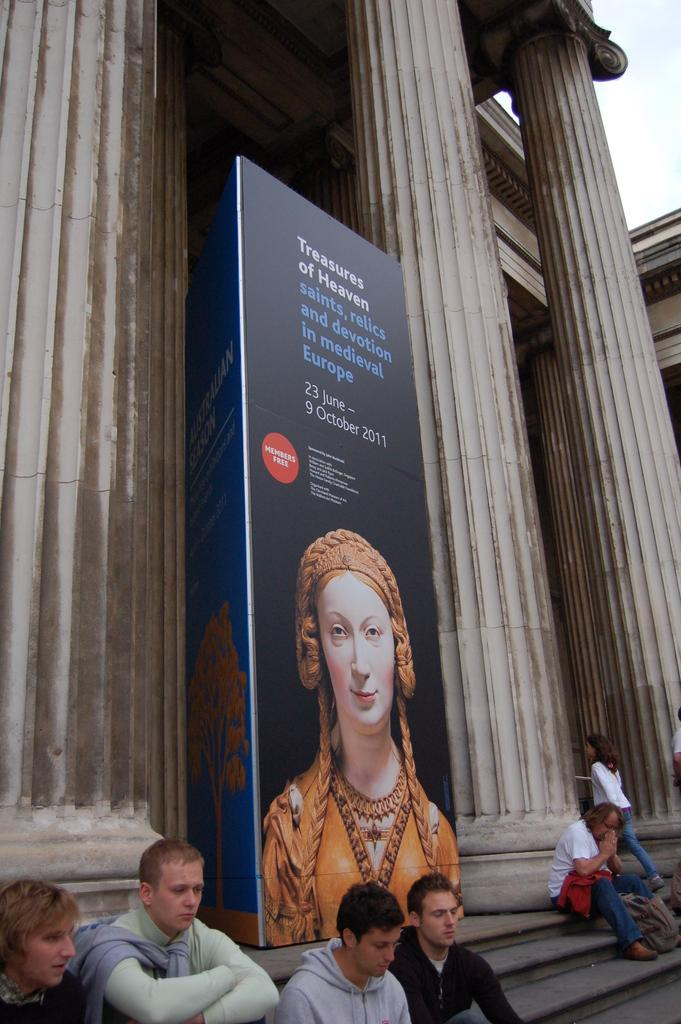What can be seen in the image that people might use to move between different levels? There are steps in the image that people might use to move between different levels. What are the people in the image doing on the steps? Some people are sitting on the steps. What architectural features can be seen in the background of the image? There are pillars in the background of the image. What is hanging or attached to the steps or pillars in the image? There is a banner in the image. What is written or depicted on the banner? Something is written on the banner, and there is a picture of a lady on the banner. Can you tell me how many frogs are hopping around on the steps in the image? There are no frogs present in the image; it only features people sitting on the steps, pillars in the background, and a banner. 